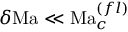<formula> <loc_0><loc_0><loc_500><loc_500>\delta M a \ll M a _ { c } ^ { ( f l ) }</formula> 